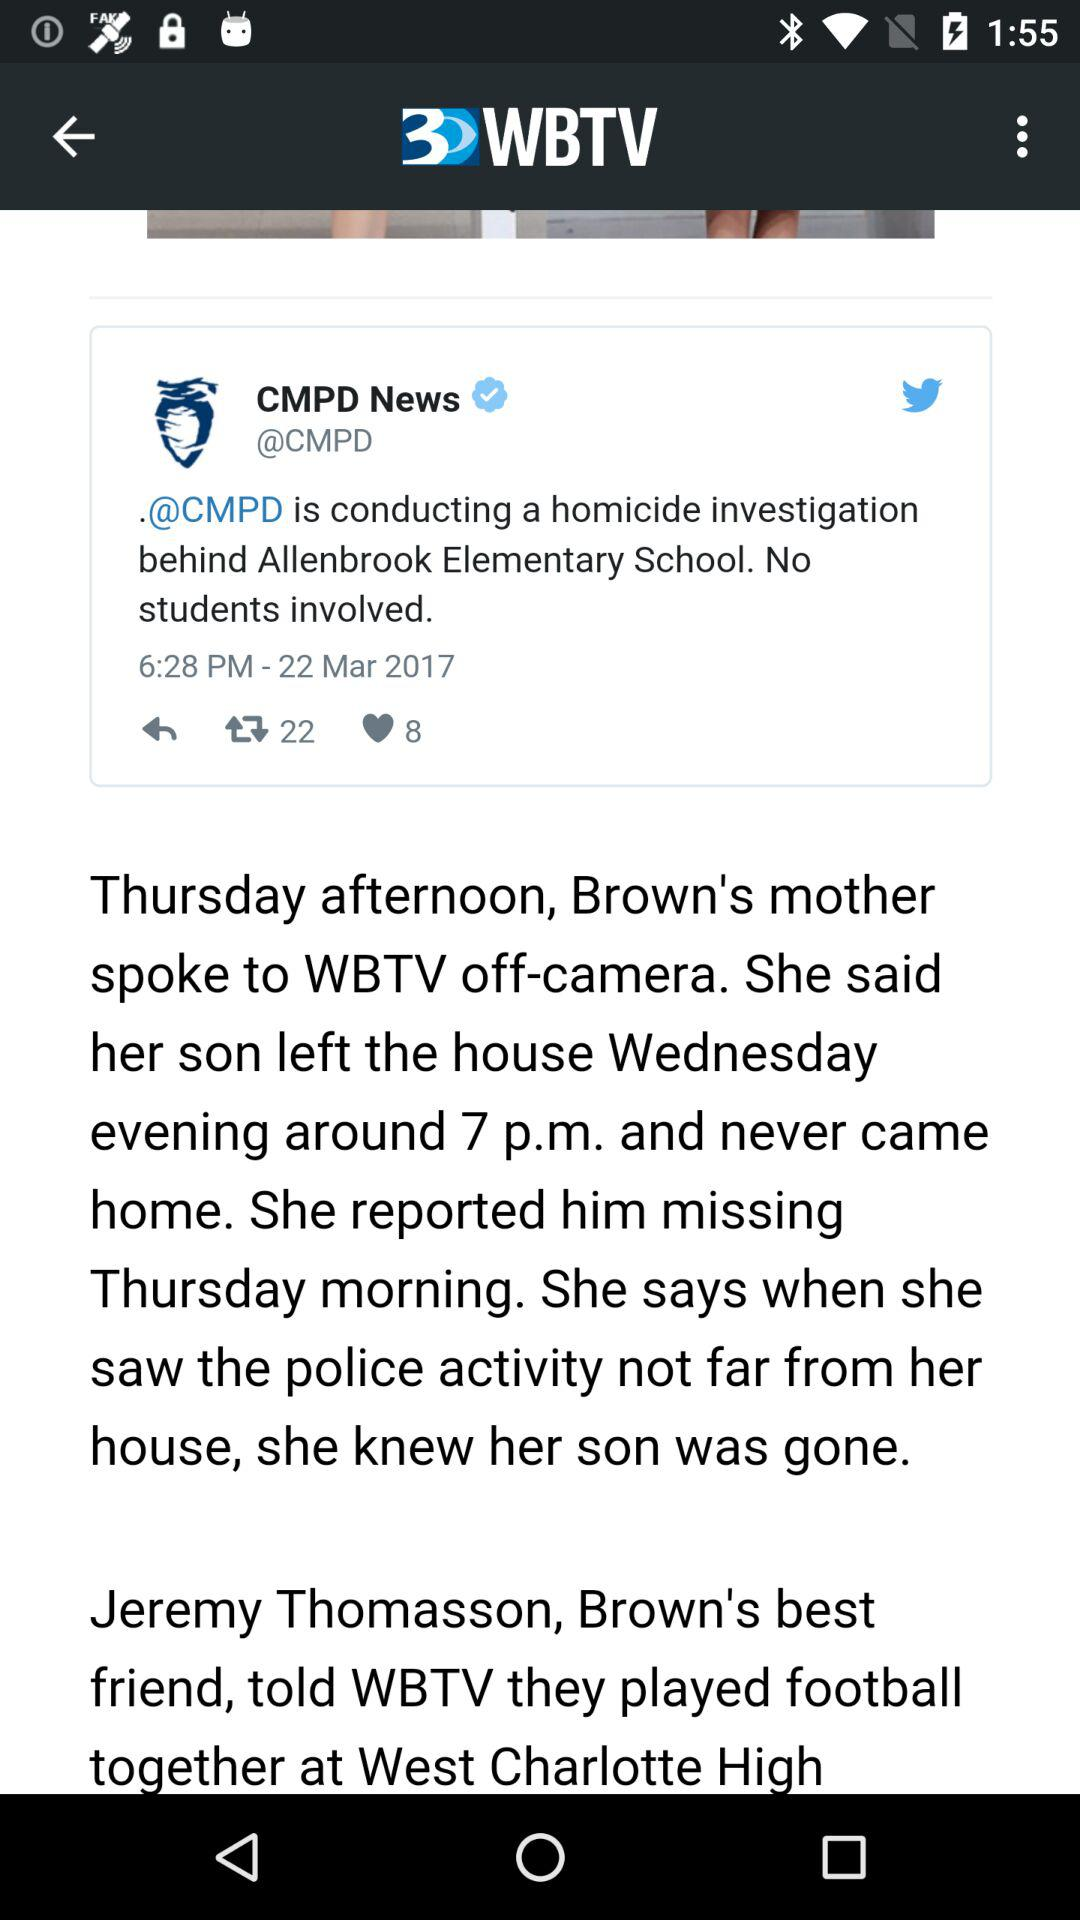How many more retweets than likes does the tweet have?
Answer the question using a single word or phrase. 14 